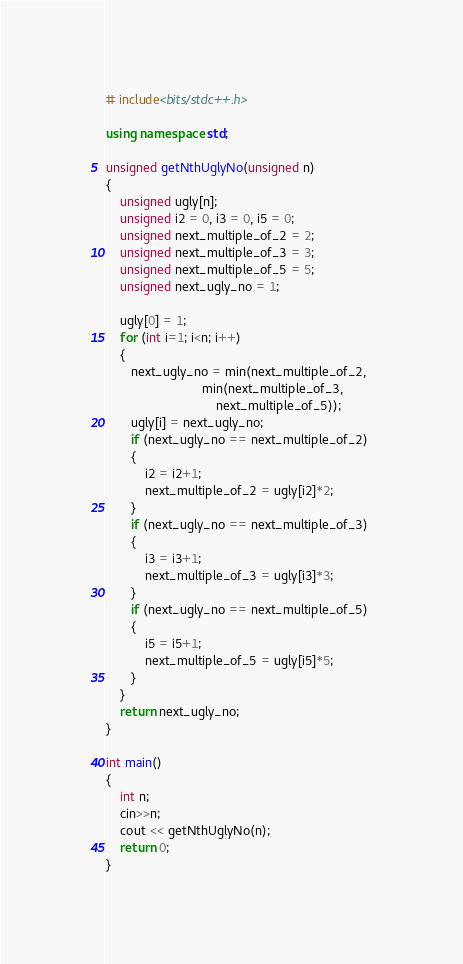<code> <loc_0><loc_0><loc_500><loc_500><_C++_># include<bits/stdc++.h> 

using namespace std; 

unsigned getNthUglyNo(unsigned n) 
{ 
    unsigned ugly[n];  
    unsigned i2 = 0, i3 = 0, i5 = 0; 
    unsigned next_multiple_of_2 = 2; 
    unsigned next_multiple_of_3 = 3; 
    unsigned next_multiple_of_5 = 5; 
    unsigned next_ugly_no = 1; 
  
    ugly[0] = 1; 
    for (int i=1; i<n; i++) 
    { 
       next_ugly_no = min(next_multiple_of_2, 
                           min(next_multiple_of_3, 
                               next_multiple_of_5)); 
       ugly[i] = next_ugly_no; 
       if (next_ugly_no == next_multiple_of_2) 
       { 
           i2 = i2+1; 
           next_multiple_of_2 = ugly[i2]*2; 
       } 
       if (next_ugly_no == next_multiple_of_3) 
       { 
           i3 = i3+1; 
           next_multiple_of_3 = ugly[i3]*3; 
       } 
       if (next_ugly_no == next_multiple_of_5) 
       { 
           i5 = i5+1; 
           next_multiple_of_5 = ugly[i5]*5; 
       } 
    } 
    return next_ugly_no; 
} 
  
int main() 
{ 
    int n;
	cin>>n; 
    cout << getNthUglyNo(n); 
    return 0; 
} 
</code> 